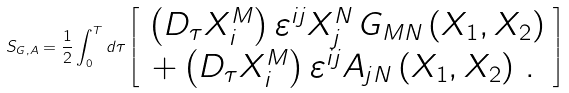Convert formula to latex. <formula><loc_0><loc_0><loc_500><loc_500>S _ { G , A } = \frac { 1 } { 2 } \int _ { 0 } ^ { T } d \tau \left [ \begin{array} { c } \left ( D _ { \tau } X _ { i } ^ { M } \right ) \varepsilon ^ { i j } X _ { j } ^ { N } \, G _ { M N } \left ( X _ { 1 } , X _ { 2 } \right ) \\ + \left ( D _ { \tau } X _ { i } ^ { M } \right ) \varepsilon ^ { i j } A _ { j N } \left ( X _ { 1 } , X _ { 2 } \right ) \, . \, \end{array} \right ]</formula> 